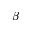<formula> <loc_0><loc_0><loc_500><loc_500>\beta</formula> 